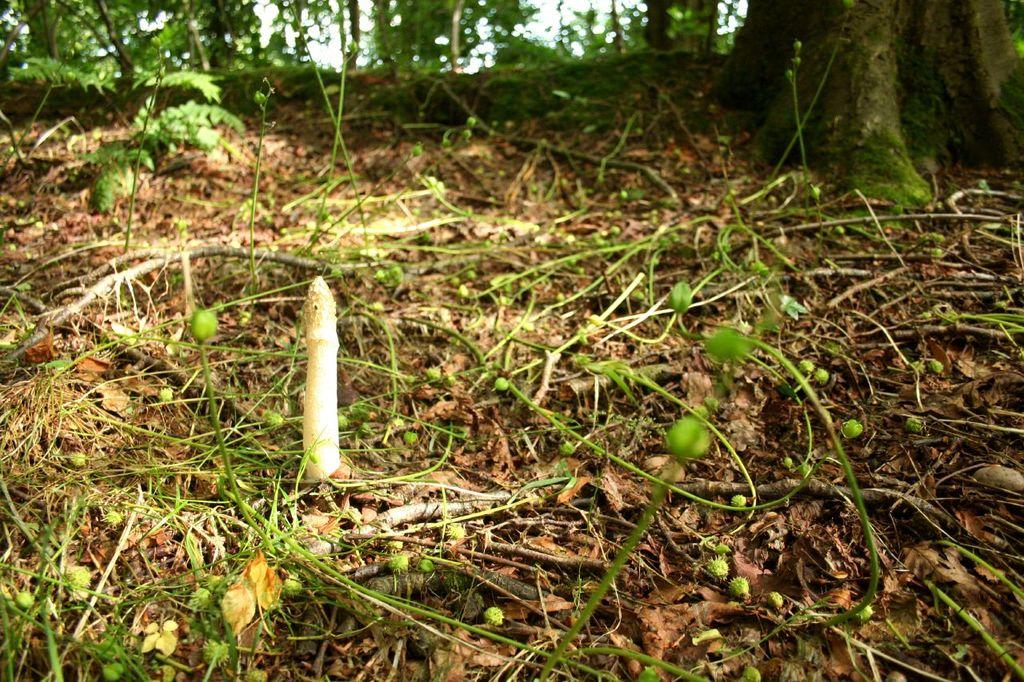What type of vegetation can be seen in the image? There are plants, trees, and grass in the image. Are there any fruits visible in the image? Yes, small fruits are present in the grass. Can you see a chair in the image? There is no chair present in the image. How do the plants join together to form a pattern in the image? The plants do not join together to form a pattern in the image; they are separate and distinct. 